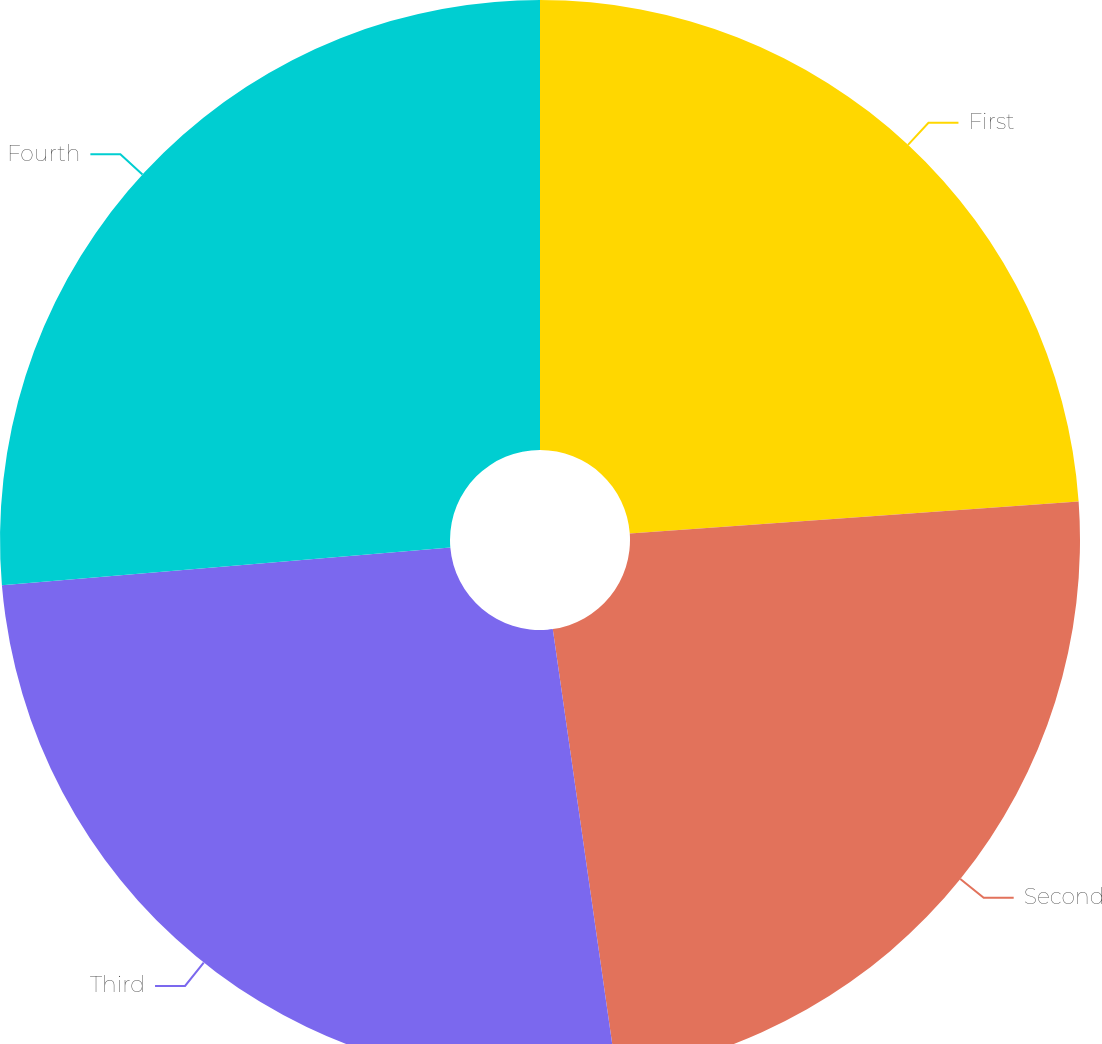Convert chart to OTSL. <chart><loc_0><loc_0><loc_500><loc_500><pie_chart><fcel>First<fcel>Second<fcel>Third<fcel>Fourth<nl><fcel>23.87%<fcel>23.87%<fcel>25.93%<fcel>26.34%<nl></chart> 